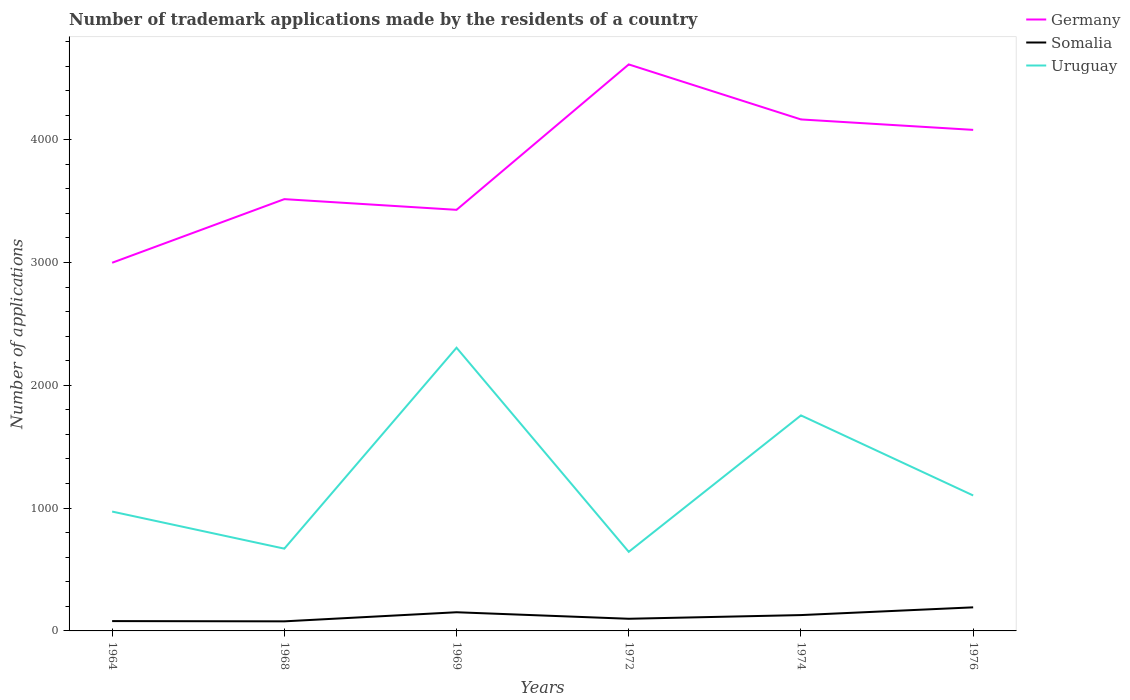Does the line corresponding to Germany intersect with the line corresponding to Somalia?
Provide a succinct answer. No. In which year was the number of trademark applications made by the residents in Germany maximum?
Make the answer very short. 1964. What is the total number of trademark applications made by the residents in Somalia in the graph?
Provide a succinct answer. -40. What is the difference between the highest and the second highest number of trademark applications made by the residents in Germany?
Your response must be concise. 1615. What is the difference between the highest and the lowest number of trademark applications made by the residents in Uruguay?
Provide a short and direct response. 2. Is the number of trademark applications made by the residents in Somalia strictly greater than the number of trademark applications made by the residents in Uruguay over the years?
Offer a terse response. Yes. How many lines are there?
Ensure brevity in your answer.  3. How many years are there in the graph?
Your response must be concise. 6. Does the graph contain grids?
Provide a succinct answer. No. Where does the legend appear in the graph?
Provide a short and direct response. Top right. What is the title of the graph?
Your answer should be very brief. Number of trademark applications made by the residents of a country. Does "Finland" appear as one of the legend labels in the graph?
Provide a succinct answer. No. What is the label or title of the X-axis?
Make the answer very short. Years. What is the label or title of the Y-axis?
Offer a terse response. Number of applications. What is the Number of applications in Germany in 1964?
Make the answer very short. 2998. What is the Number of applications of Uruguay in 1964?
Your answer should be very brief. 972. What is the Number of applications of Germany in 1968?
Keep it short and to the point. 3516. What is the Number of applications of Uruguay in 1968?
Ensure brevity in your answer.  670. What is the Number of applications of Germany in 1969?
Your response must be concise. 3429. What is the Number of applications of Somalia in 1969?
Give a very brief answer. 152. What is the Number of applications in Uruguay in 1969?
Offer a very short reply. 2306. What is the Number of applications of Germany in 1972?
Provide a short and direct response. 4613. What is the Number of applications of Somalia in 1972?
Your answer should be compact. 99. What is the Number of applications of Uruguay in 1972?
Keep it short and to the point. 644. What is the Number of applications in Germany in 1974?
Offer a very short reply. 4165. What is the Number of applications of Somalia in 1974?
Your answer should be compact. 129. What is the Number of applications of Uruguay in 1974?
Provide a short and direct response. 1755. What is the Number of applications in Germany in 1976?
Your answer should be very brief. 4080. What is the Number of applications in Somalia in 1976?
Provide a succinct answer. 192. What is the Number of applications in Uruguay in 1976?
Make the answer very short. 1103. Across all years, what is the maximum Number of applications in Germany?
Your response must be concise. 4613. Across all years, what is the maximum Number of applications of Somalia?
Your answer should be very brief. 192. Across all years, what is the maximum Number of applications in Uruguay?
Ensure brevity in your answer.  2306. Across all years, what is the minimum Number of applications in Germany?
Keep it short and to the point. 2998. Across all years, what is the minimum Number of applications of Uruguay?
Offer a very short reply. 644. What is the total Number of applications of Germany in the graph?
Offer a terse response. 2.28e+04. What is the total Number of applications of Somalia in the graph?
Your response must be concise. 730. What is the total Number of applications of Uruguay in the graph?
Provide a succinct answer. 7450. What is the difference between the Number of applications in Germany in 1964 and that in 1968?
Make the answer very short. -518. What is the difference between the Number of applications in Somalia in 1964 and that in 1968?
Provide a short and direct response. 2. What is the difference between the Number of applications in Uruguay in 1964 and that in 1968?
Your answer should be very brief. 302. What is the difference between the Number of applications of Germany in 1964 and that in 1969?
Your response must be concise. -431. What is the difference between the Number of applications of Somalia in 1964 and that in 1969?
Your response must be concise. -72. What is the difference between the Number of applications of Uruguay in 1964 and that in 1969?
Your answer should be compact. -1334. What is the difference between the Number of applications of Germany in 1964 and that in 1972?
Make the answer very short. -1615. What is the difference between the Number of applications of Uruguay in 1964 and that in 1972?
Provide a short and direct response. 328. What is the difference between the Number of applications of Germany in 1964 and that in 1974?
Offer a very short reply. -1167. What is the difference between the Number of applications in Somalia in 1964 and that in 1974?
Your answer should be very brief. -49. What is the difference between the Number of applications in Uruguay in 1964 and that in 1974?
Your answer should be compact. -783. What is the difference between the Number of applications of Germany in 1964 and that in 1976?
Offer a terse response. -1082. What is the difference between the Number of applications of Somalia in 1964 and that in 1976?
Offer a terse response. -112. What is the difference between the Number of applications in Uruguay in 1964 and that in 1976?
Your answer should be very brief. -131. What is the difference between the Number of applications in Somalia in 1968 and that in 1969?
Your response must be concise. -74. What is the difference between the Number of applications of Uruguay in 1968 and that in 1969?
Give a very brief answer. -1636. What is the difference between the Number of applications of Germany in 1968 and that in 1972?
Make the answer very short. -1097. What is the difference between the Number of applications in Uruguay in 1968 and that in 1972?
Keep it short and to the point. 26. What is the difference between the Number of applications of Germany in 1968 and that in 1974?
Make the answer very short. -649. What is the difference between the Number of applications of Somalia in 1968 and that in 1974?
Your answer should be compact. -51. What is the difference between the Number of applications of Uruguay in 1968 and that in 1974?
Your response must be concise. -1085. What is the difference between the Number of applications of Germany in 1968 and that in 1976?
Give a very brief answer. -564. What is the difference between the Number of applications of Somalia in 1968 and that in 1976?
Ensure brevity in your answer.  -114. What is the difference between the Number of applications of Uruguay in 1968 and that in 1976?
Provide a short and direct response. -433. What is the difference between the Number of applications of Germany in 1969 and that in 1972?
Provide a short and direct response. -1184. What is the difference between the Number of applications in Somalia in 1969 and that in 1972?
Ensure brevity in your answer.  53. What is the difference between the Number of applications in Uruguay in 1969 and that in 1972?
Your response must be concise. 1662. What is the difference between the Number of applications in Germany in 1969 and that in 1974?
Offer a terse response. -736. What is the difference between the Number of applications of Uruguay in 1969 and that in 1974?
Provide a short and direct response. 551. What is the difference between the Number of applications in Germany in 1969 and that in 1976?
Make the answer very short. -651. What is the difference between the Number of applications of Somalia in 1969 and that in 1976?
Provide a succinct answer. -40. What is the difference between the Number of applications in Uruguay in 1969 and that in 1976?
Your answer should be compact. 1203. What is the difference between the Number of applications in Germany in 1972 and that in 1974?
Your answer should be compact. 448. What is the difference between the Number of applications in Somalia in 1972 and that in 1974?
Ensure brevity in your answer.  -30. What is the difference between the Number of applications in Uruguay in 1972 and that in 1974?
Keep it short and to the point. -1111. What is the difference between the Number of applications in Germany in 1972 and that in 1976?
Your response must be concise. 533. What is the difference between the Number of applications of Somalia in 1972 and that in 1976?
Make the answer very short. -93. What is the difference between the Number of applications in Uruguay in 1972 and that in 1976?
Keep it short and to the point. -459. What is the difference between the Number of applications in Germany in 1974 and that in 1976?
Make the answer very short. 85. What is the difference between the Number of applications of Somalia in 1974 and that in 1976?
Give a very brief answer. -63. What is the difference between the Number of applications of Uruguay in 1974 and that in 1976?
Provide a short and direct response. 652. What is the difference between the Number of applications of Germany in 1964 and the Number of applications of Somalia in 1968?
Keep it short and to the point. 2920. What is the difference between the Number of applications of Germany in 1964 and the Number of applications of Uruguay in 1968?
Make the answer very short. 2328. What is the difference between the Number of applications of Somalia in 1964 and the Number of applications of Uruguay in 1968?
Your answer should be compact. -590. What is the difference between the Number of applications of Germany in 1964 and the Number of applications of Somalia in 1969?
Ensure brevity in your answer.  2846. What is the difference between the Number of applications in Germany in 1964 and the Number of applications in Uruguay in 1969?
Offer a terse response. 692. What is the difference between the Number of applications in Somalia in 1964 and the Number of applications in Uruguay in 1969?
Provide a short and direct response. -2226. What is the difference between the Number of applications of Germany in 1964 and the Number of applications of Somalia in 1972?
Your answer should be very brief. 2899. What is the difference between the Number of applications in Germany in 1964 and the Number of applications in Uruguay in 1972?
Offer a terse response. 2354. What is the difference between the Number of applications in Somalia in 1964 and the Number of applications in Uruguay in 1972?
Offer a very short reply. -564. What is the difference between the Number of applications in Germany in 1964 and the Number of applications in Somalia in 1974?
Your answer should be very brief. 2869. What is the difference between the Number of applications in Germany in 1964 and the Number of applications in Uruguay in 1974?
Offer a terse response. 1243. What is the difference between the Number of applications in Somalia in 1964 and the Number of applications in Uruguay in 1974?
Offer a very short reply. -1675. What is the difference between the Number of applications of Germany in 1964 and the Number of applications of Somalia in 1976?
Ensure brevity in your answer.  2806. What is the difference between the Number of applications of Germany in 1964 and the Number of applications of Uruguay in 1976?
Your answer should be very brief. 1895. What is the difference between the Number of applications in Somalia in 1964 and the Number of applications in Uruguay in 1976?
Make the answer very short. -1023. What is the difference between the Number of applications in Germany in 1968 and the Number of applications in Somalia in 1969?
Give a very brief answer. 3364. What is the difference between the Number of applications of Germany in 1968 and the Number of applications of Uruguay in 1969?
Make the answer very short. 1210. What is the difference between the Number of applications of Somalia in 1968 and the Number of applications of Uruguay in 1969?
Make the answer very short. -2228. What is the difference between the Number of applications of Germany in 1968 and the Number of applications of Somalia in 1972?
Offer a very short reply. 3417. What is the difference between the Number of applications of Germany in 1968 and the Number of applications of Uruguay in 1972?
Ensure brevity in your answer.  2872. What is the difference between the Number of applications of Somalia in 1968 and the Number of applications of Uruguay in 1972?
Offer a very short reply. -566. What is the difference between the Number of applications of Germany in 1968 and the Number of applications of Somalia in 1974?
Your answer should be very brief. 3387. What is the difference between the Number of applications of Germany in 1968 and the Number of applications of Uruguay in 1974?
Keep it short and to the point. 1761. What is the difference between the Number of applications of Somalia in 1968 and the Number of applications of Uruguay in 1974?
Give a very brief answer. -1677. What is the difference between the Number of applications in Germany in 1968 and the Number of applications in Somalia in 1976?
Your response must be concise. 3324. What is the difference between the Number of applications of Germany in 1968 and the Number of applications of Uruguay in 1976?
Ensure brevity in your answer.  2413. What is the difference between the Number of applications of Somalia in 1968 and the Number of applications of Uruguay in 1976?
Your response must be concise. -1025. What is the difference between the Number of applications in Germany in 1969 and the Number of applications in Somalia in 1972?
Offer a very short reply. 3330. What is the difference between the Number of applications of Germany in 1969 and the Number of applications of Uruguay in 1972?
Offer a very short reply. 2785. What is the difference between the Number of applications of Somalia in 1969 and the Number of applications of Uruguay in 1972?
Give a very brief answer. -492. What is the difference between the Number of applications of Germany in 1969 and the Number of applications of Somalia in 1974?
Keep it short and to the point. 3300. What is the difference between the Number of applications of Germany in 1969 and the Number of applications of Uruguay in 1974?
Provide a succinct answer. 1674. What is the difference between the Number of applications of Somalia in 1969 and the Number of applications of Uruguay in 1974?
Provide a short and direct response. -1603. What is the difference between the Number of applications in Germany in 1969 and the Number of applications in Somalia in 1976?
Your answer should be very brief. 3237. What is the difference between the Number of applications in Germany in 1969 and the Number of applications in Uruguay in 1976?
Your response must be concise. 2326. What is the difference between the Number of applications in Somalia in 1969 and the Number of applications in Uruguay in 1976?
Offer a terse response. -951. What is the difference between the Number of applications of Germany in 1972 and the Number of applications of Somalia in 1974?
Ensure brevity in your answer.  4484. What is the difference between the Number of applications of Germany in 1972 and the Number of applications of Uruguay in 1974?
Your answer should be very brief. 2858. What is the difference between the Number of applications of Somalia in 1972 and the Number of applications of Uruguay in 1974?
Offer a very short reply. -1656. What is the difference between the Number of applications in Germany in 1972 and the Number of applications in Somalia in 1976?
Provide a short and direct response. 4421. What is the difference between the Number of applications in Germany in 1972 and the Number of applications in Uruguay in 1976?
Give a very brief answer. 3510. What is the difference between the Number of applications of Somalia in 1972 and the Number of applications of Uruguay in 1976?
Provide a short and direct response. -1004. What is the difference between the Number of applications of Germany in 1974 and the Number of applications of Somalia in 1976?
Provide a short and direct response. 3973. What is the difference between the Number of applications of Germany in 1974 and the Number of applications of Uruguay in 1976?
Your response must be concise. 3062. What is the difference between the Number of applications in Somalia in 1974 and the Number of applications in Uruguay in 1976?
Your answer should be compact. -974. What is the average Number of applications in Germany per year?
Give a very brief answer. 3800.17. What is the average Number of applications of Somalia per year?
Your answer should be very brief. 121.67. What is the average Number of applications in Uruguay per year?
Offer a terse response. 1241.67. In the year 1964, what is the difference between the Number of applications of Germany and Number of applications of Somalia?
Provide a succinct answer. 2918. In the year 1964, what is the difference between the Number of applications in Germany and Number of applications in Uruguay?
Provide a succinct answer. 2026. In the year 1964, what is the difference between the Number of applications in Somalia and Number of applications in Uruguay?
Your answer should be very brief. -892. In the year 1968, what is the difference between the Number of applications of Germany and Number of applications of Somalia?
Offer a terse response. 3438. In the year 1968, what is the difference between the Number of applications of Germany and Number of applications of Uruguay?
Give a very brief answer. 2846. In the year 1968, what is the difference between the Number of applications in Somalia and Number of applications in Uruguay?
Provide a short and direct response. -592. In the year 1969, what is the difference between the Number of applications in Germany and Number of applications in Somalia?
Give a very brief answer. 3277. In the year 1969, what is the difference between the Number of applications in Germany and Number of applications in Uruguay?
Your answer should be very brief. 1123. In the year 1969, what is the difference between the Number of applications in Somalia and Number of applications in Uruguay?
Give a very brief answer. -2154. In the year 1972, what is the difference between the Number of applications of Germany and Number of applications of Somalia?
Your answer should be very brief. 4514. In the year 1972, what is the difference between the Number of applications of Germany and Number of applications of Uruguay?
Provide a short and direct response. 3969. In the year 1972, what is the difference between the Number of applications of Somalia and Number of applications of Uruguay?
Your response must be concise. -545. In the year 1974, what is the difference between the Number of applications of Germany and Number of applications of Somalia?
Offer a very short reply. 4036. In the year 1974, what is the difference between the Number of applications of Germany and Number of applications of Uruguay?
Your response must be concise. 2410. In the year 1974, what is the difference between the Number of applications of Somalia and Number of applications of Uruguay?
Your answer should be very brief. -1626. In the year 1976, what is the difference between the Number of applications of Germany and Number of applications of Somalia?
Provide a succinct answer. 3888. In the year 1976, what is the difference between the Number of applications in Germany and Number of applications in Uruguay?
Make the answer very short. 2977. In the year 1976, what is the difference between the Number of applications of Somalia and Number of applications of Uruguay?
Your answer should be very brief. -911. What is the ratio of the Number of applications of Germany in 1964 to that in 1968?
Offer a terse response. 0.85. What is the ratio of the Number of applications in Somalia in 1964 to that in 1968?
Offer a very short reply. 1.03. What is the ratio of the Number of applications of Uruguay in 1964 to that in 1968?
Make the answer very short. 1.45. What is the ratio of the Number of applications of Germany in 1964 to that in 1969?
Your answer should be very brief. 0.87. What is the ratio of the Number of applications of Somalia in 1964 to that in 1969?
Your answer should be compact. 0.53. What is the ratio of the Number of applications in Uruguay in 1964 to that in 1969?
Give a very brief answer. 0.42. What is the ratio of the Number of applications in Germany in 1964 to that in 1972?
Provide a succinct answer. 0.65. What is the ratio of the Number of applications of Somalia in 1964 to that in 1972?
Your answer should be compact. 0.81. What is the ratio of the Number of applications of Uruguay in 1964 to that in 1972?
Give a very brief answer. 1.51. What is the ratio of the Number of applications in Germany in 1964 to that in 1974?
Provide a succinct answer. 0.72. What is the ratio of the Number of applications of Somalia in 1964 to that in 1974?
Provide a short and direct response. 0.62. What is the ratio of the Number of applications of Uruguay in 1964 to that in 1974?
Your answer should be compact. 0.55. What is the ratio of the Number of applications of Germany in 1964 to that in 1976?
Your answer should be very brief. 0.73. What is the ratio of the Number of applications in Somalia in 1964 to that in 1976?
Ensure brevity in your answer.  0.42. What is the ratio of the Number of applications of Uruguay in 1964 to that in 1976?
Offer a terse response. 0.88. What is the ratio of the Number of applications in Germany in 1968 to that in 1969?
Your answer should be compact. 1.03. What is the ratio of the Number of applications in Somalia in 1968 to that in 1969?
Your answer should be compact. 0.51. What is the ratio of the Number of applications in Uruguay in 1968 to that in 1969?
Ensure brevity in your answer.  0.29. What is the ratio of the Number of applications of Germany in 1968 to that in 1972?
Keep it short and to the point. 0.76. What is the ratio of the Number of applications of Somalia in 1968 to that in 1972?
Your response must be concise. 0.79. What is the ratio of the Number of applications of Uruguay in 1968 to that in 1972?
Make the answer very short. 1.04. What is the ratio of the Number of applications of Germany in 1968 to that in 1974?
Provide a short and direct response. 0.84. What is the ratio of the Number of applications of Somalia in 1968 to that in 1974?
Keep it short and to the point. 0.6. What is the ratio of the Number of applications in Uruguay in 1968 to that in 1974?
Provide a succinct answer. 0.38. What is the ratio of the Number of applications of Germany in 1968 to that in 1976?
Give a very brief answer. 0.86. What is the ratio of the Number of applications in Somalia in 1968 to that in 1976?
Give a very brief answer. 0.41. What is the ratio of the Number of applications in Uruguay in 1968 to that in 1976?
Offer a terse response. 0.61. What is the ratio of the Number of applications of Germany in 1969 to that in 1972?
Keep it short and to the point. 0.74. What is the ratio of the Number of applications of Somalia in 1969 to that in 1972?
Your answer should be very brief. 1.54. What is the ratio of the Number of applications of Uruguay in 1969 to that in 1972?
Your response must be concise. 3.58. What is the ratio of the Number of applications in Germany in 1969 to that in 1974?
Give a very brief answer. 0.82. What is the ratio of the Number of applications in Somalia in 1969 to that in 1974?
Keep it short and to the point. 1.18. What is the ratio of the Number of applications of Uruguay in 1969 to that in 1974?
Provide a short and direct response. 1.31. What is the ratio of the Number of applications of Germany in 1969 to that in 1976?
Provide a short and direct response. 0.84. What is the ratio of the Number of applications in Somalia in 1969 to that in 1976?
Make the answer very short. 0.79. What is the ratio of the Number of applications in Uruguay in 1969 to that in 1976?
Give a very brief answer. 2.09. What is the ratio of the Number of applications in Germany in 1972 to that in 1974?
Your answer should be very brief. 1.11. What is the ratio of the Number of applications of Somalia in 1972 to that in 1974?
Provide a short and direct response. 0.77. What is the ratio of the Number of applications of Uruguay in 1972 to that in 1974?
Provide a succinct answer. 0.37. What is the ratio of the Number of applications in Germany in 1972 to that in 1976?
Ensure brevity in your answer.  1.13. What is the ratio of the Number of applications in Somalia in 1972 to that in 1976?
Offer a terse response. 0.52. What is the ratio of the Number of applications in Uruguay in 1972 to that in 1976?
Provide a short and direct response. 0.58. What is the ratio of the Number of applications in Germany in 1974 to that in 1976?
Provide a succinct answer. 1.02. What is the ratio of the Number of applications in Somalia in 1974 to that in 1976?
Provide a succinct answer. 0.67. What is the ratio of the Number of applications in Uruguay in 1974 to that in 1976?
Offer a terse response. 1.59. What is the difference between the highest and the second highest Number of applications in Germany?
Offer a very short reply. 448. What is the difference between the highest and the second highest Number of applications of Uruguay?
Ensure brevity in your answer.  551. What is the difference between the highest and the lowest Number of applications of Germany?
Provide a short and direct response. 1615. What is the difference between the highest and the lowest Number of applications of Somalia?
Your response must be concise. 114. What is the difference between the highest and the lowest Number of applications in Uruguay?
Ensure brevity in your answer.  1662. 